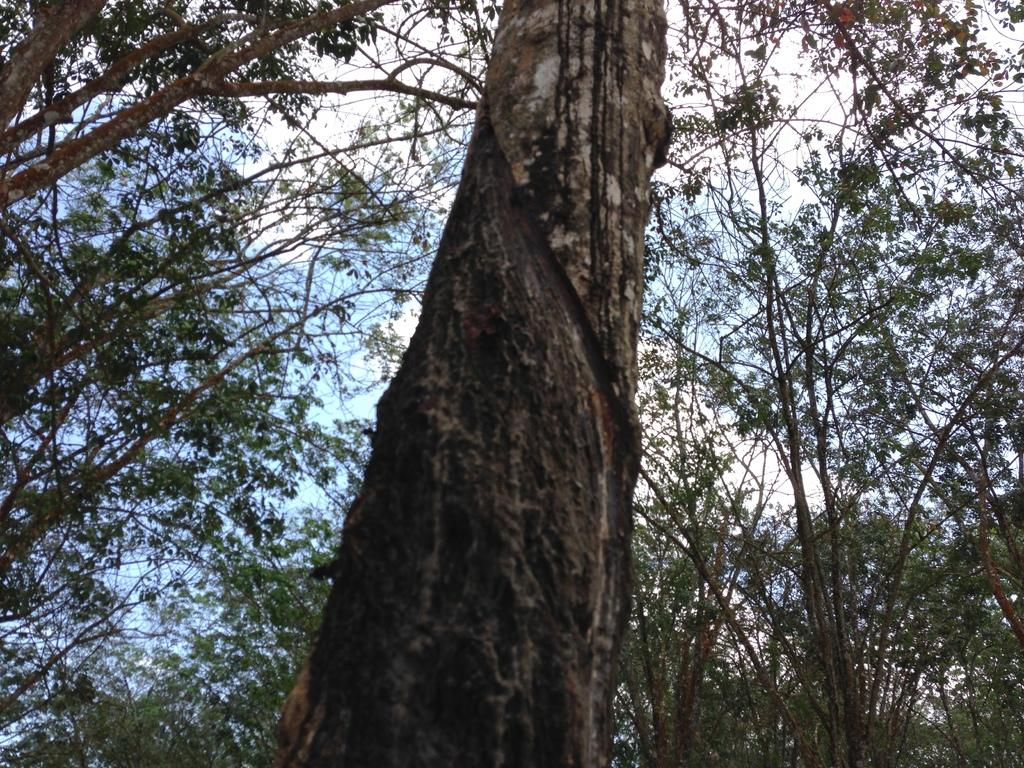What type of vegetation can be seen in the image? There are trees in the image. What part of the natural environment is visible in the image? The sky is visible in the background of the image. Can you hear the family of snakes crying in the image? There is no reference to snakes or crying in the image, so it is not possible to answer that question. 